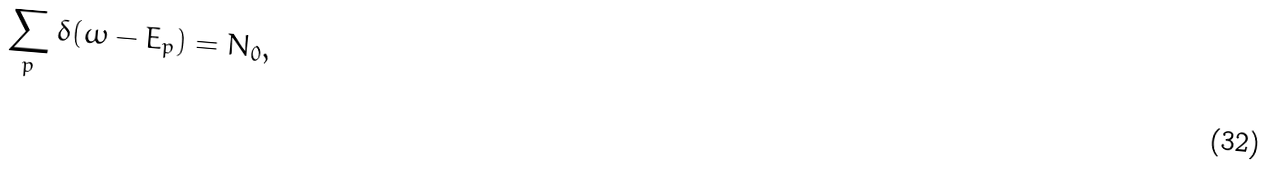<formula> <loc_0><loc_0><loc_500><loc_500>\sum _ { p } \delta ( \omega - E _ { p } ) = N _ { 0 } ,</formula> 